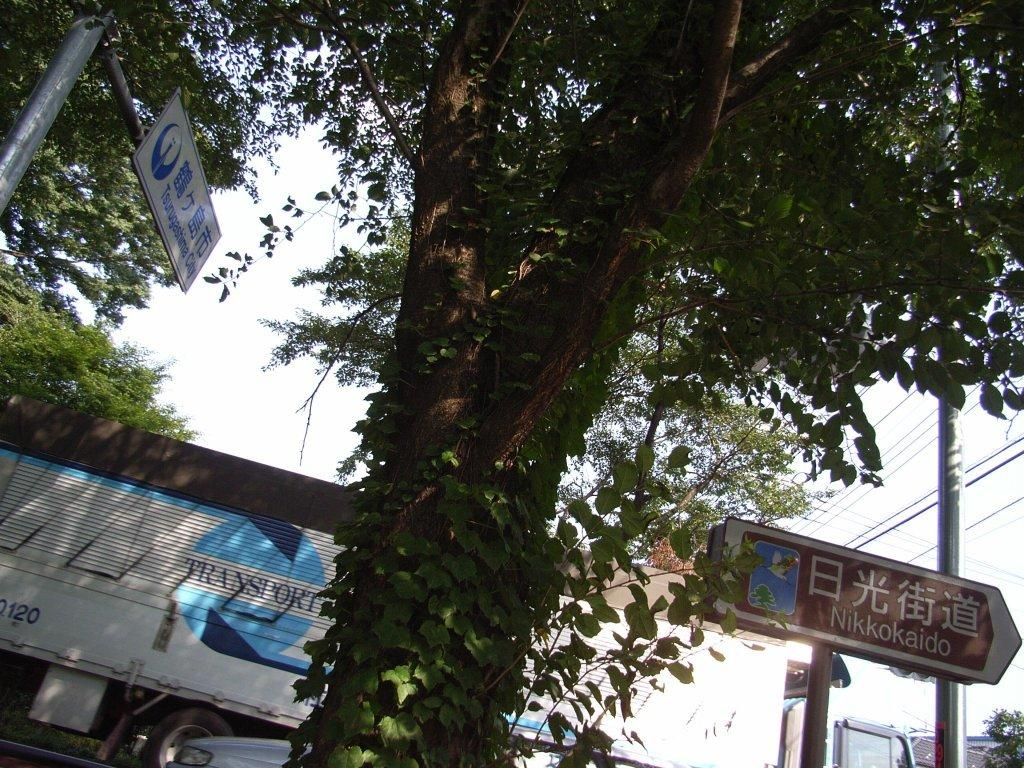What type of natural feature is present in the image? There is a tall tree in the image. What is located behind the tree? There is a vehicle behind the tree. How many direction boards are in the image? There are two direction boards in the image. What can be seen in the background of the image? The sky is visible in the background of the image. What type of pot is placed on the hill in the image? There is no hill or pot present in the image. What type of apparel is the tree wearing in the image? Trees do not wear apparel, as they are plants and not people. 